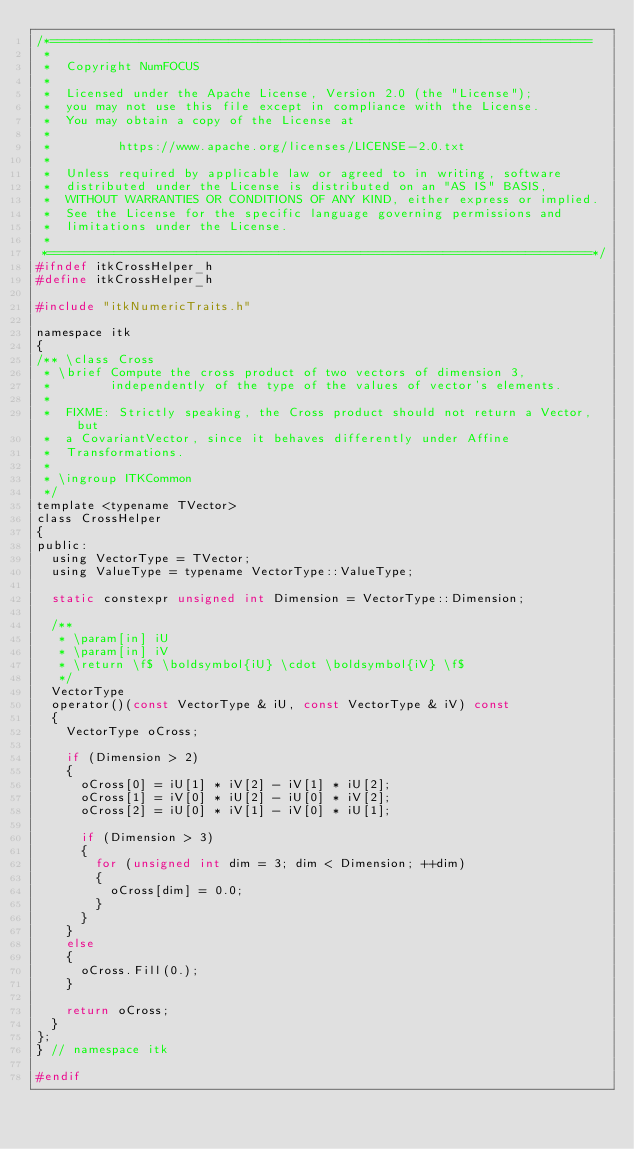Convert code to text. <code><loc_0><loc_0><loc_500><loc_500><_C_>/*=========================================================================
 *
 *  Copyright NumFOCUS
 *
 *  Licensed under the Apache License, Version 2.0 (the "License");
 *  you may not use this file except in compliance with the License.
 *  You may obtain a copy of the License at
 *
 *         https://www.apache.org/licenses/LICENSE-2.0.txt
 *
 *  Unless required by applicable law or agreed to in writing, software
 *  distributed under the License is distributed on an "AS IS" BASIS,
 *  WITHOUT WARRANTIES OR CONDITIONS OF ANY KIND, either express or implied.
 *  See the License for the specific language governing permissions and
 *  limitations under the License.
 *
 *=========================================================================*/
#ifndef itkCrossHelper_h
#define itkCrossHelper_h

#include "itkNumericTraits.h"

namespace itk
{
/** \class Cross
 * \brief Compute the cross product of two vectors of dimension 3,
 *        independently of the type of the values of vector's elements.
 *
 *  FIXME: Strictly speaking, the Cross product should not return a Vector, but
 *  a CovariantVector, since it behaves differently under Affine
 *  Transformations.
 *
 * \ingroup ITKCommon
 */
template <typename TVector>
class CrossHelper
{
public:
  using VectorType = TVector;
  using ValueType = typename VectorType::ValueType;

  static constexpr unsigned int Dimension = VectorType::Dimension;

  /**
   * \param[in] iU
   * \param[in] iV
   * \return \f$ \boldsymbol{iU} \cdot \boldsymbol{iV} \f$
   */
  VectorType
  operator()(const VectorType & iU, const VectorType & iV) const
  {
    VectorType oCross;

    if (Dimension > 2)
    {
      oCross[0] = iU[1] * iV[2] - iV[1] * iU[2];
      oCross[1] = iV[0] * iU[2] - iU[0] * iV[2];
      oCross[2] = iU[0] * iV[1] - iV[0] * iU[1];

      if (Dimension > 3)
      {
        for (unsigned int dim = 3; dim < Dimension; ++dim)
        {
          oCross[dim] = 0.0;
        }
      }
    }
    else
    {
      oCross.Fill(0.);
    }

    return oCross;
  }
};
} // namespace itk

#endif
</code> 